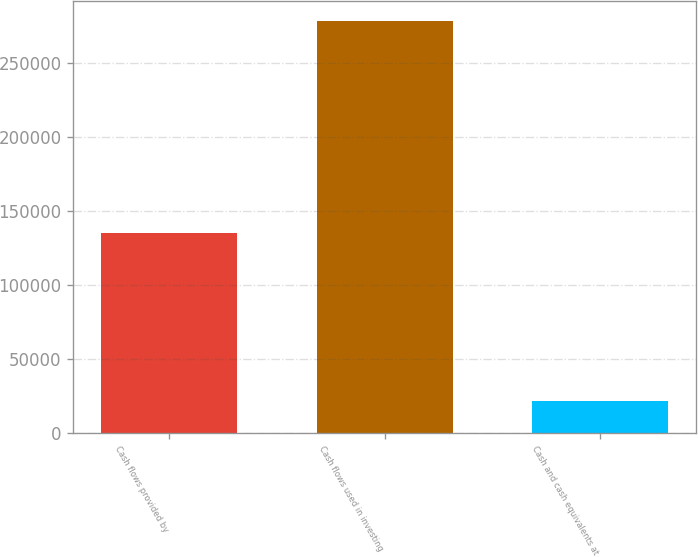Convert chart to OTSL. <chart><loc_0><loc_0><loc_500><loc_500><bar_chart><fcel>Cash flows provided by<fcel>Cash flows used in investing<fcel>Cash and cash equivalents at<nl><fcel>134901<fcel>278136<fcel>21359<nl></chart> 